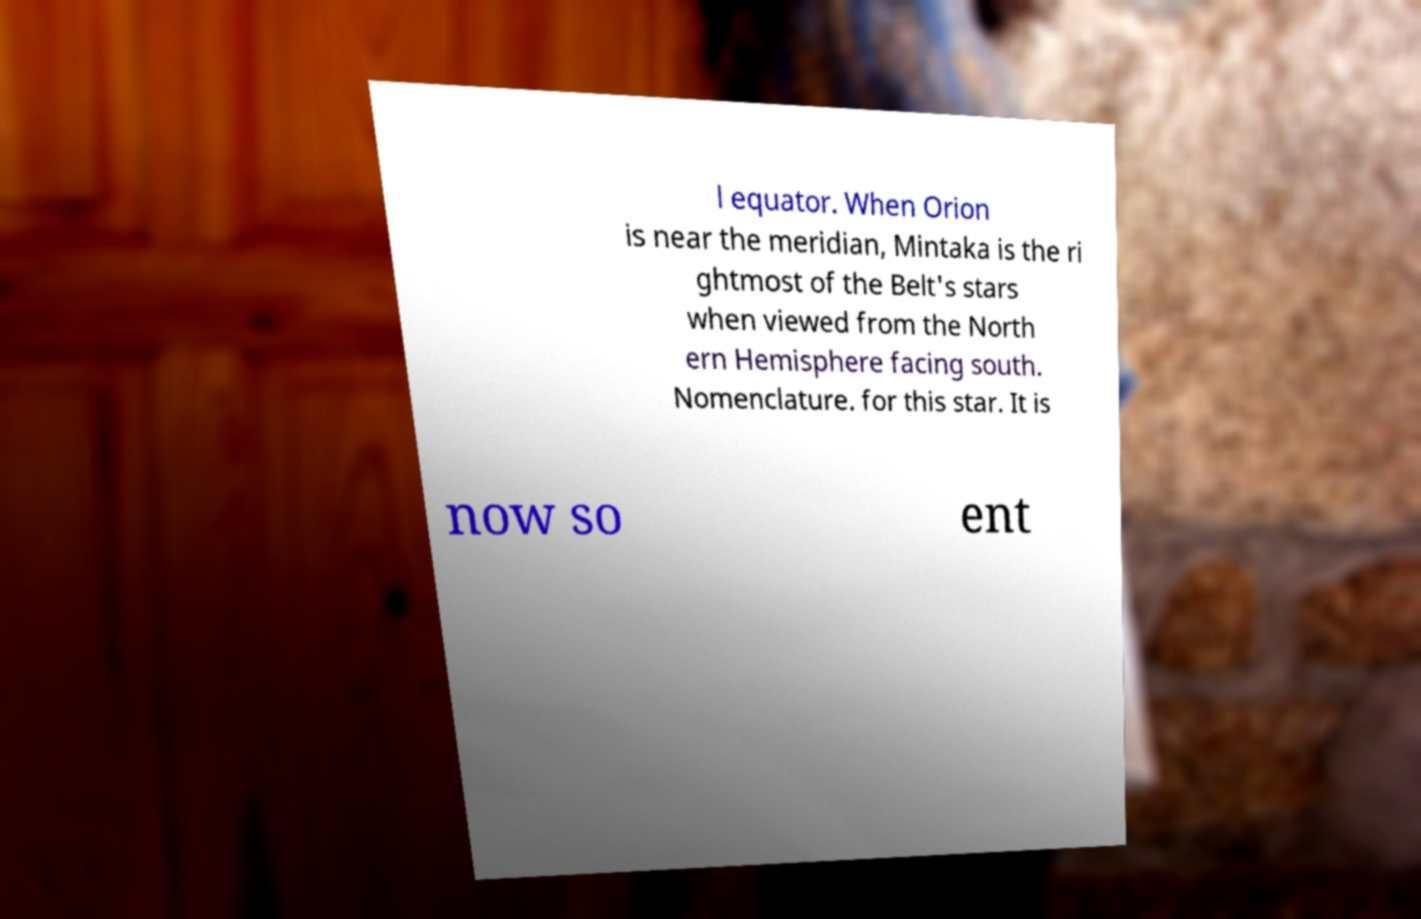I need the written content from this picture converted into text. Can you do that? l equator. When Orion is near the meridian, Mintaka is the ri ghtmost of the Belt's stars when viewed from the North ern Hemisphere facing south. Nomenclature. for this star. It is now so ent 